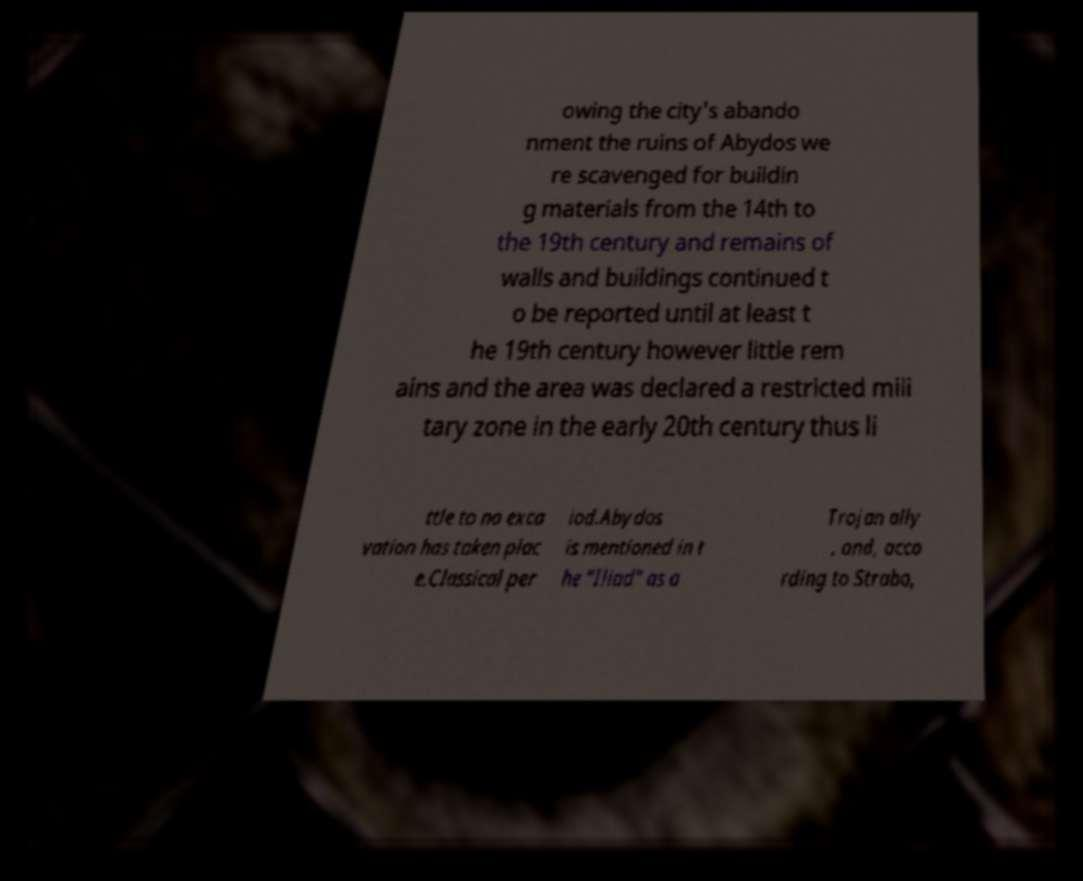Please identify and transcribe the text found in this image. owing the city's abando nment the ruins of Abydos we re scavenged for buildin g materials from the 14th to the 19th century and remains of walls and buildings continued t o be reported until at least t he 19th century however little rem ains and the area was declared a restricted mili tary zone in the early 20th century thus li ttle to no exca vation has taken plac e.Classical per iod.Abydos is mentioned in t he "Iliad" as a Trojan ally , and, acco rding to Strabo, 